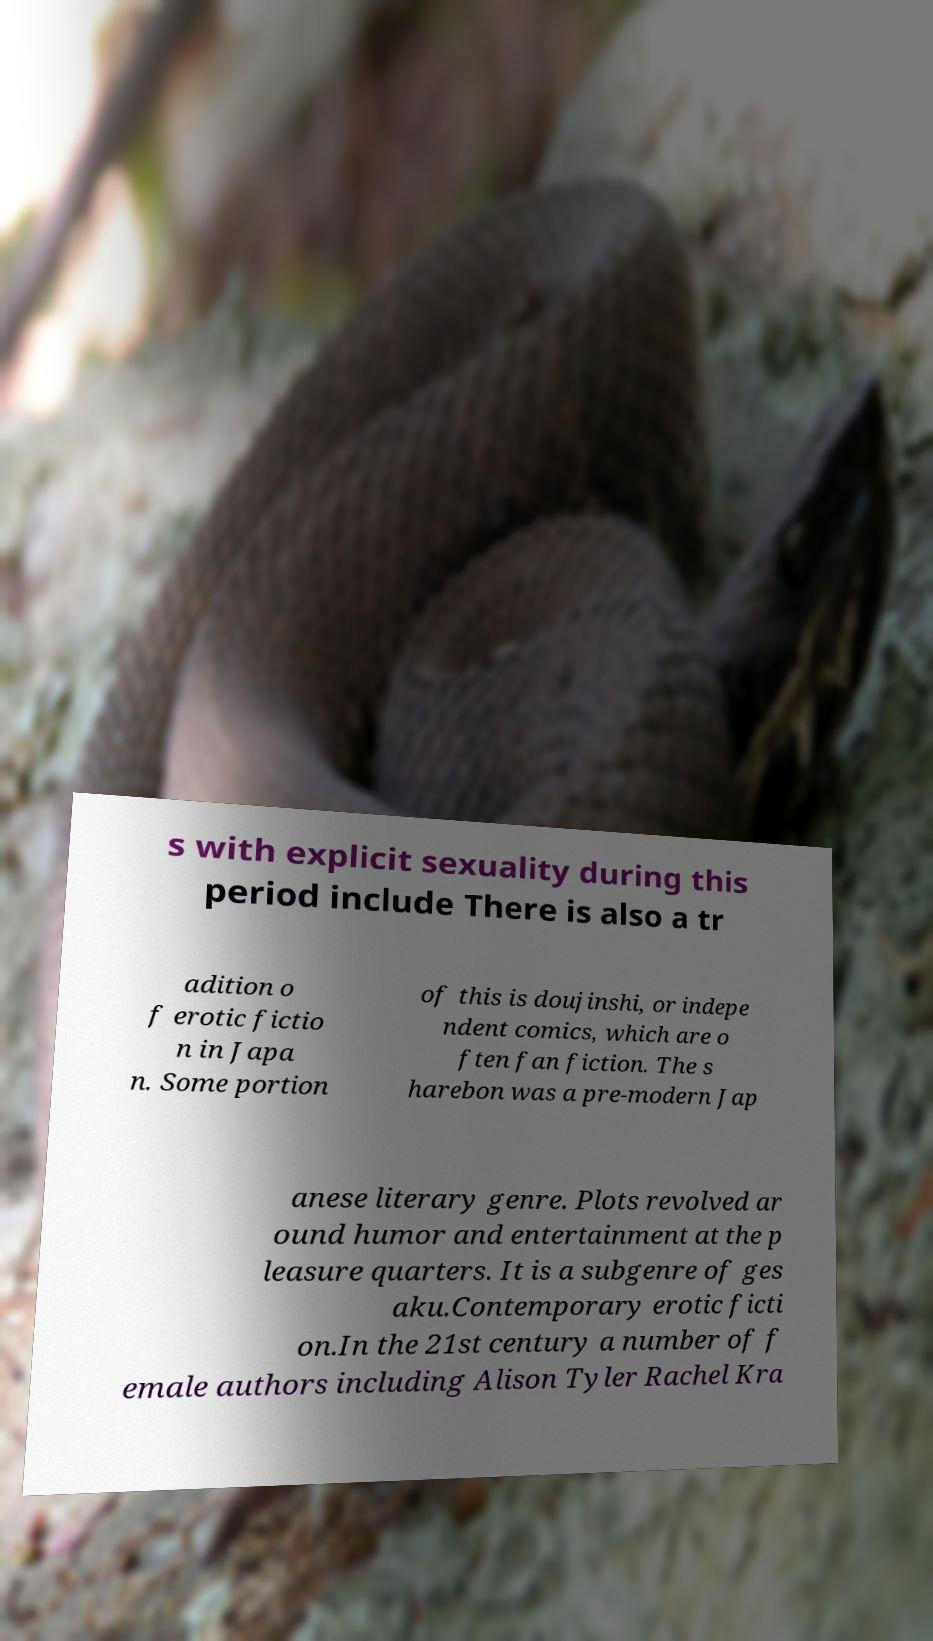Please identify and transcribe the text found in this image. s with explicit sexuality during this period include There is also a tr adition o f erotic fictio n in Japa n. Some portion of this is doujinshi, or indepe ndent comics, which are o ften fan fiction. The s harebon was a pre-modern Jap anese literary genre. Plots revolved ar ound humor and entertainment at the p leasure quarters. It is a subgenre of ges aku.Contemporary erotic ficti on.In the 21st century a number of f emale authors including Alison Tyler Rachel Kra 